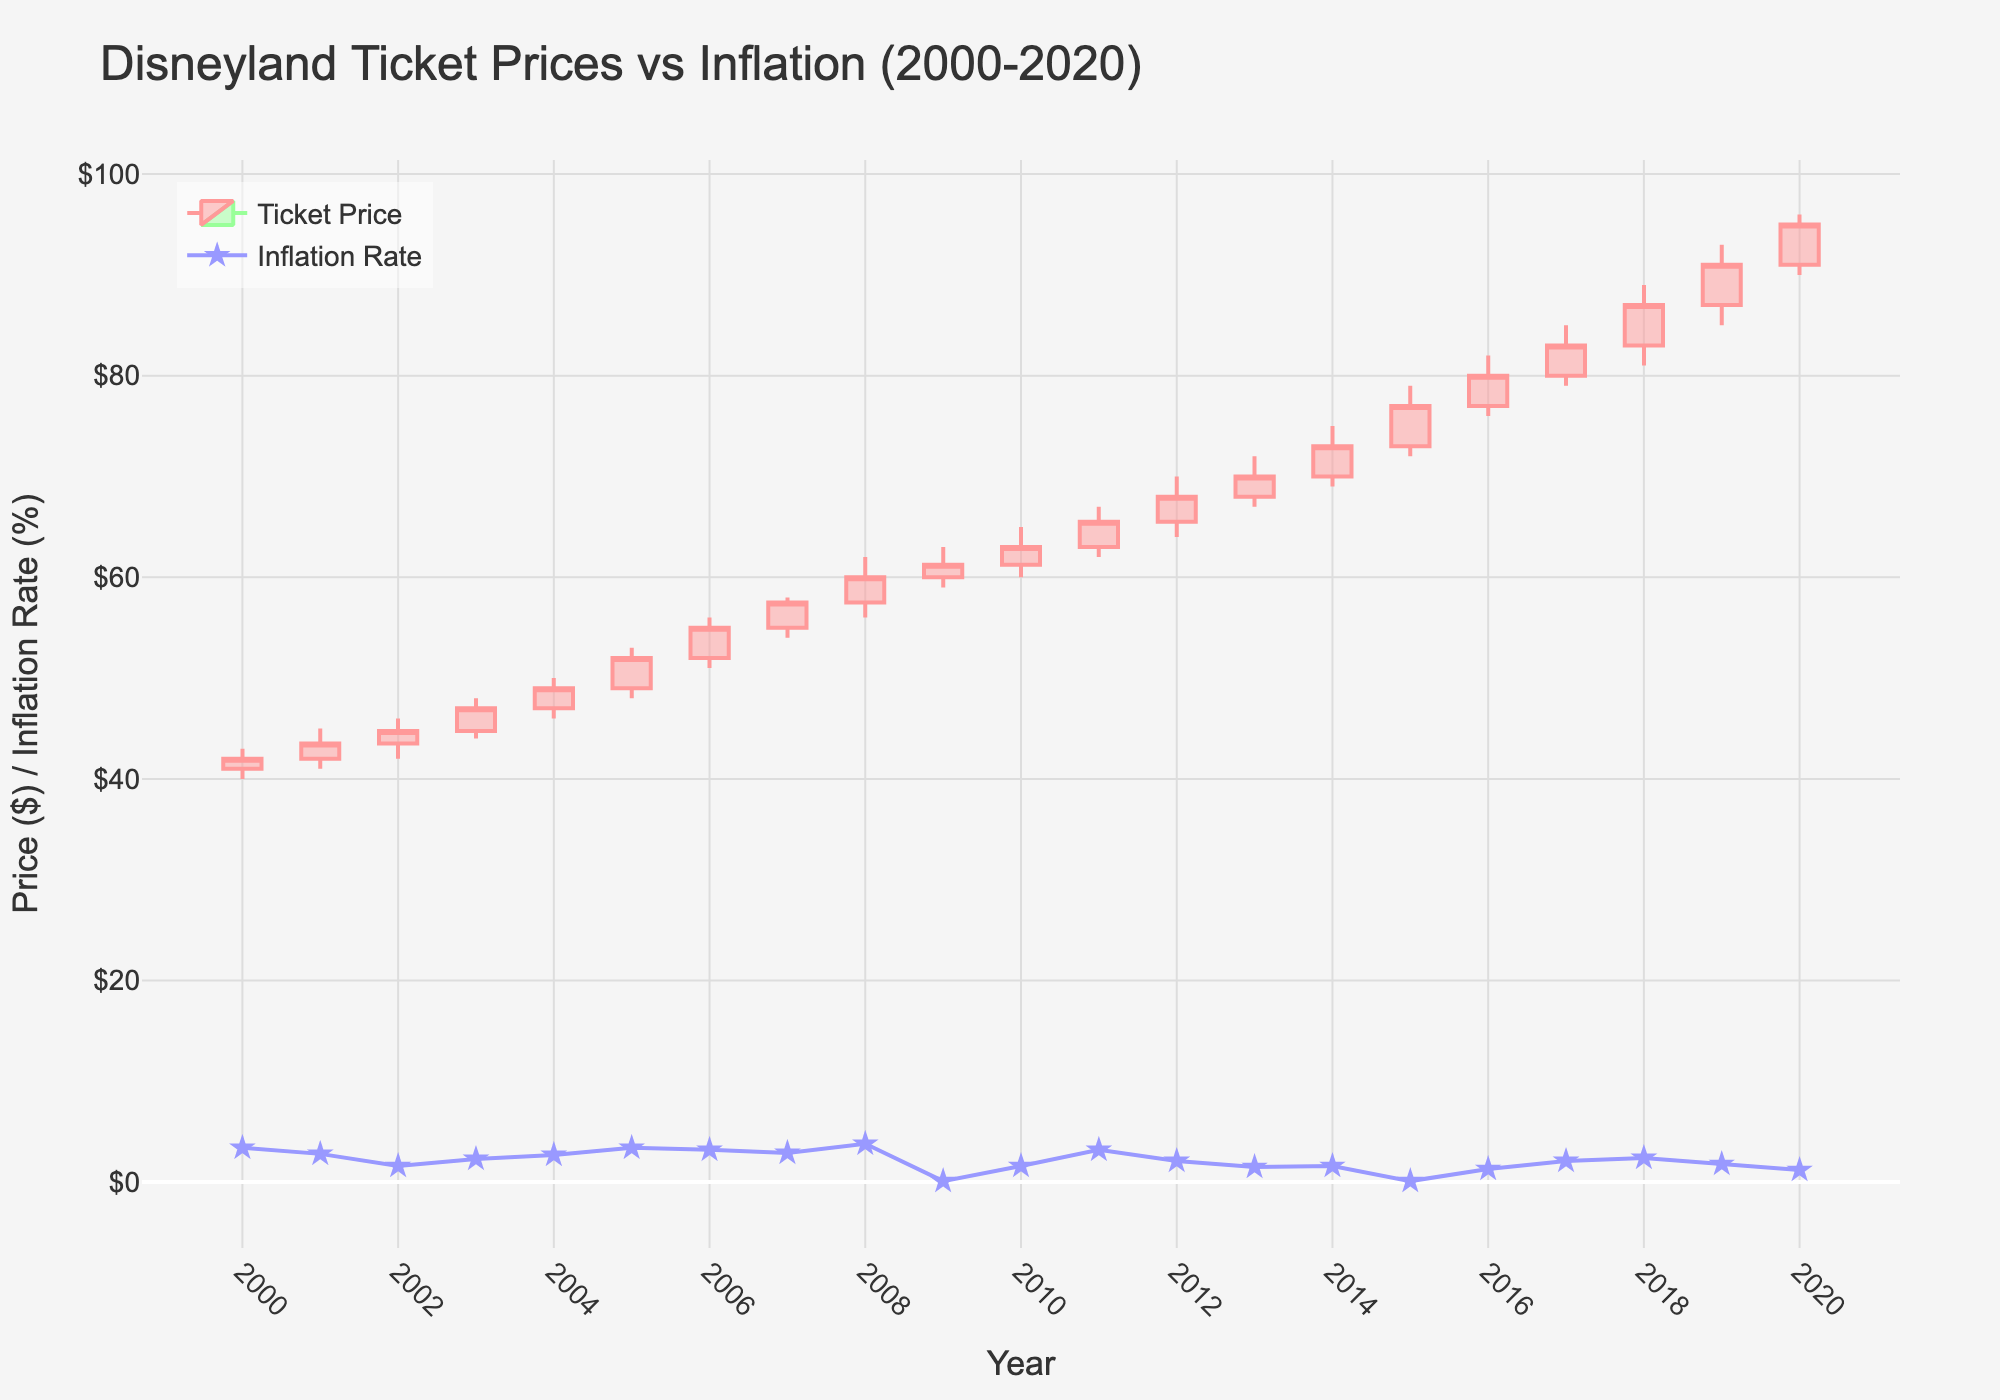what is the title of the figure? The title of the figure can be found at the top and it typically describes the subject and time frame of the data being visualized. In this case, the title is "Disneyland Ticket Prices vs Inflation (2000-2020)".
Answer: Disneyland Ticket Prices vs Inflation (2000-2020) What color represents the increasing ticket prices? The increasing ticket prices are represented by a specific line color in the candlestick plot. The increasing line color is a shade of red.
Answer: Red How many years are included in the dataset? To determine how many years are included in the dataset, observe the range of the x-axis or the labeled data points. The dataset spans from 2000 to 2020, inclusive.
Answer: 21 years In which year did the ticket price reach a high of $85? You can see the highest prices for each year by looking at the topmost part of each candlestick. In 2017, the price reached a high of $85.
Answer: 2017 How does the inflation rate trend compare between 2008 and 2009? To compare the inflation rate trends, observe the line plot for those years. The inflation rate rose from 3.8% in 2008 to 0.1% in 2009.
Answer: It decreased significantly What was the closing ticket price in 2020? The closing ticket price for each year is shown at the rightmost side of the candlesticks. For the year 2020, the closing price is $95.
Answer: $95 Which year experienced the highest inflation rate, and what was that rate? The highest inflation rate can be identified by finding the peak in the line plot of the inflation rates. In 2008, the inflation rate was 3.8%.
Answer: 2008, 3.8% How much did the highest ticket price increase from 2000 to 2005? To find the increase, subtract the highest price in 2000 ($43.00) from the highest price in 2005 ($53.00). 53 - 43 = 10.
Answer: $10 What is the average closing price for the years 2010, 2011, and 2012? Calculate the average by adding the closing prices for these years and dividing by the number of years: (63 + 65.5 + 68) / 3 = 196.5 / 3.
Answer: $65.5 Which year’s ticket price had the smallest difference between its highest and lowest price? Calculate the difference between the highest and lowest prices for each year and find the smallest value. For 2009, the difference is 63 - 59 = 4, which is the smallest among all the years.
Answer: 2009 